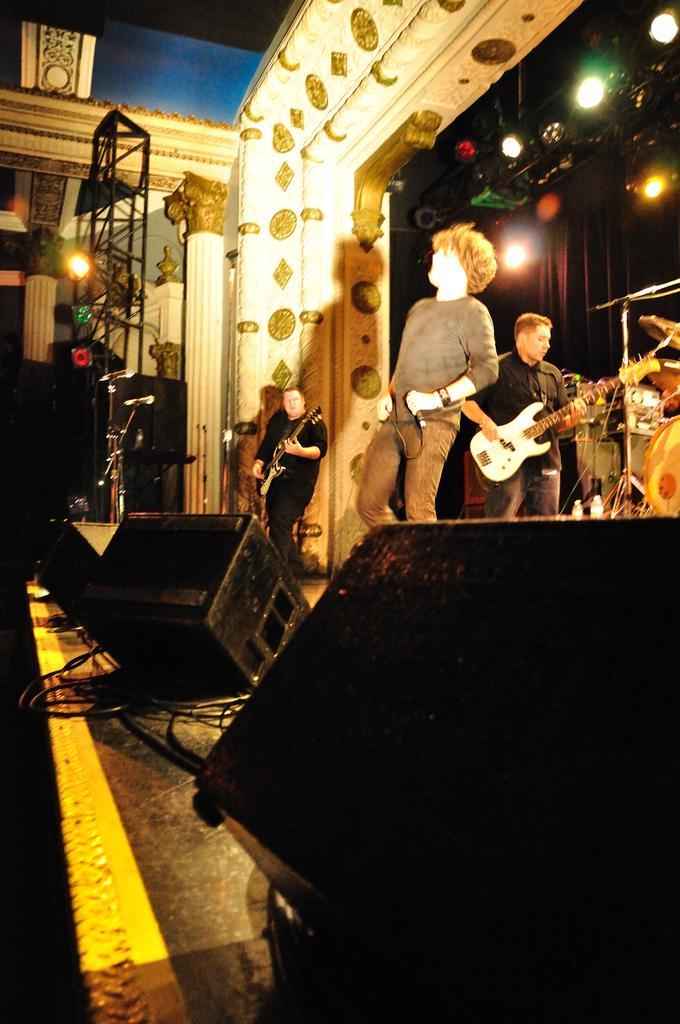Could you give a brief overview of what you see in this image? On the stage there are few men standing and playing guitar. And the men in the middle is holding mic in his hand and standing. There are some speakers on the stage. To the left side there is a pillar. And some lights. 